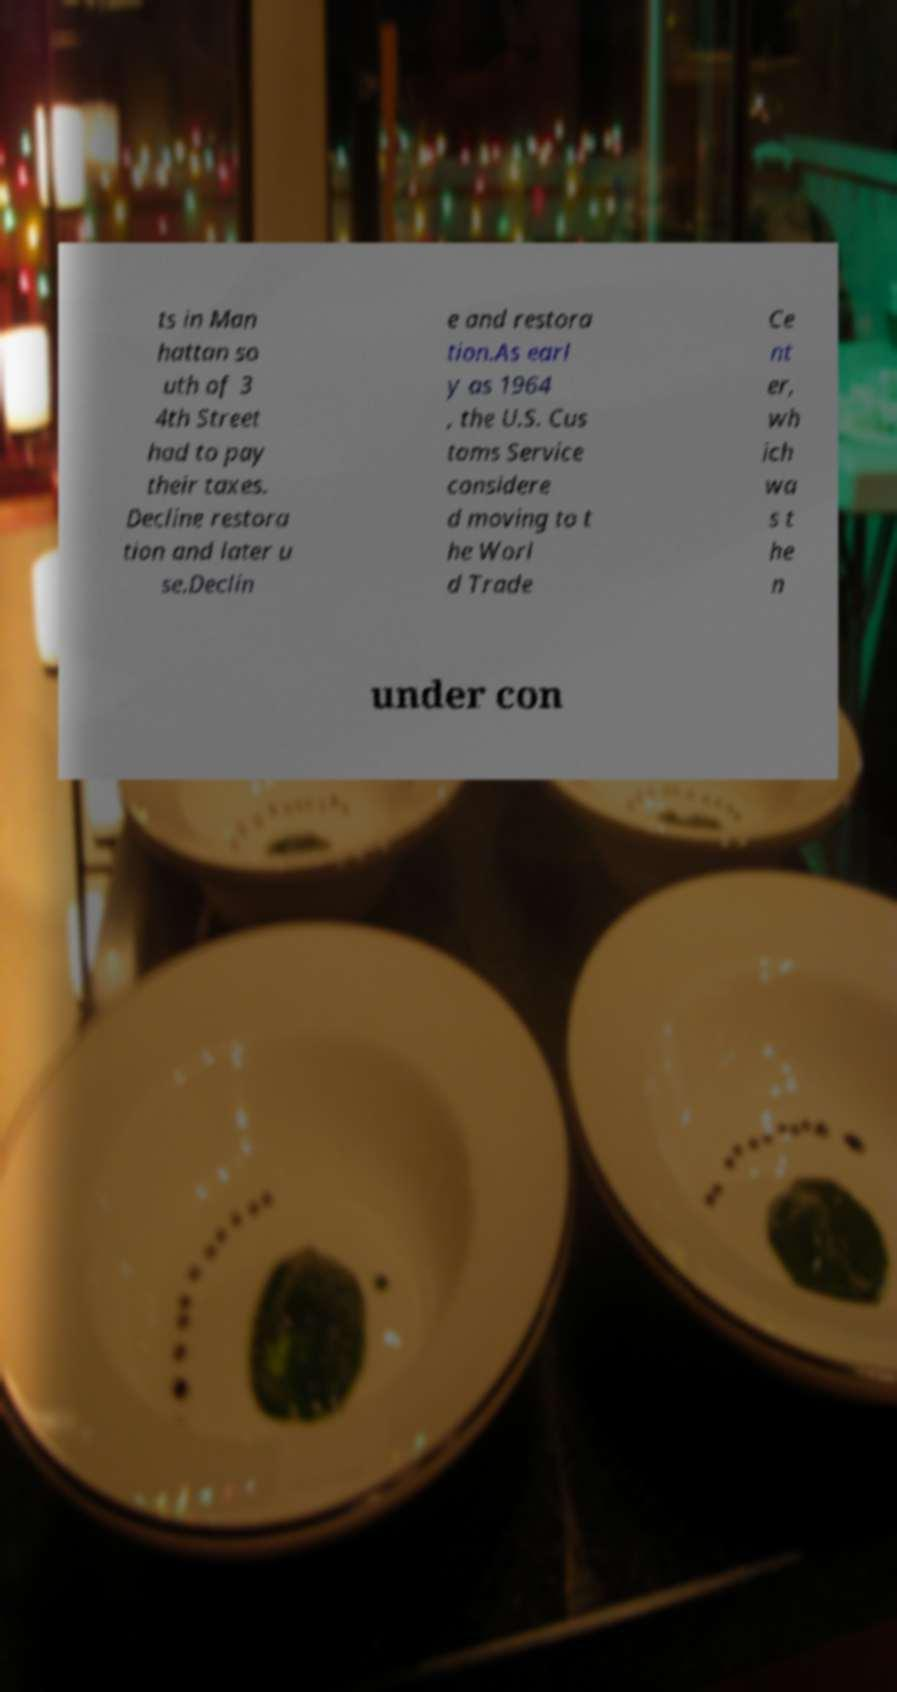What messages or text are displayed in this image? I need them in a readable, typed format. ts in Man hattan so uth of 3 4th Street had to pay their taxes. Decline restora tion and later u se.Declin e and restora tion.As earl y as 1964 , the U.S. Cus toms Service considere d moving to t he Worl d Trade Ce nt er, wh ich wa s t he n under con 